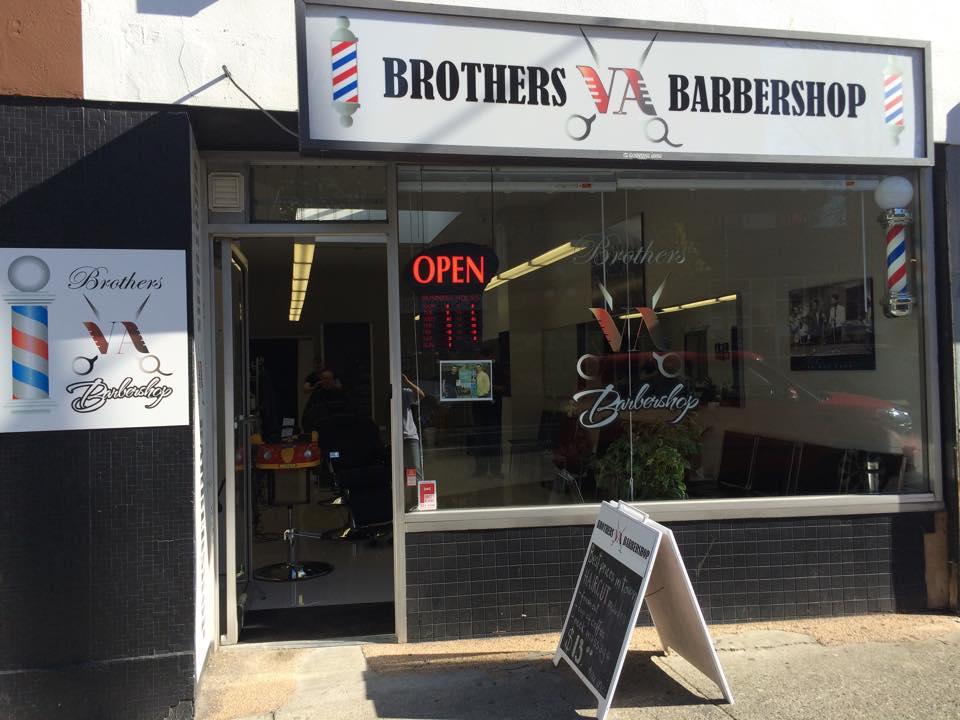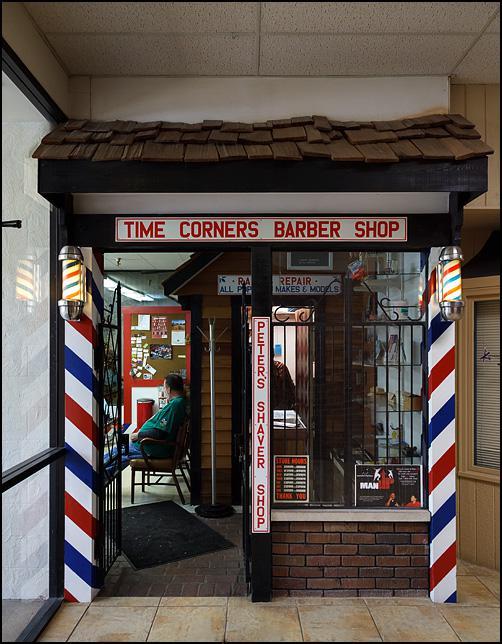The first image is the image on the left, the second image is the image on the right. Examine the images to the left and right. Is the description "One image has exactly two barber chairs." accurate? Answer yes or no. No. The first image is the image on the left, the second image is the image on the right. Considering the images on both sides, is "At least one of the images prominently features the storefront of a Barber Shop." valid? Answer yes or no. Yes. 